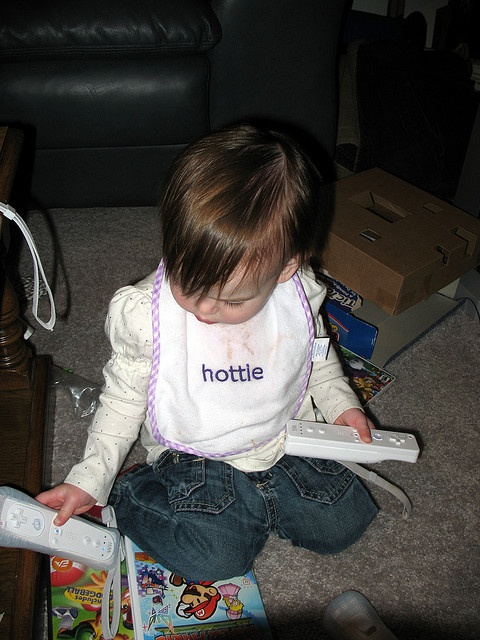Describe the objects in this image and their specific colors. I can see people in black, lightgray, darkgray, and gray tones, couch in black and gray tones, book in black, darkgray, teal, and gray tones, book in black, darkgray, darkgreen, and gray tones, and remote in black, lightgray, darkgray, and gray tones in this image. 